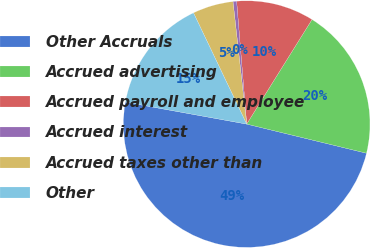Convert chart to OTSL. <chart><loc_0><loc_0><loc_500><loc_500><pie_chart><fcel>Other Accruals<fcel>Accrued advertising<fcel>Accrued payroll and employee<fcel>Accrued interest<fcel>Accrued taxes other than<fcel>Other<nl><fcel>49.06%<fcel>19.91%<fcel>10.19%<fcel>0.47%<fcel>5.33%<fcel>15.05%<nl></chart> 